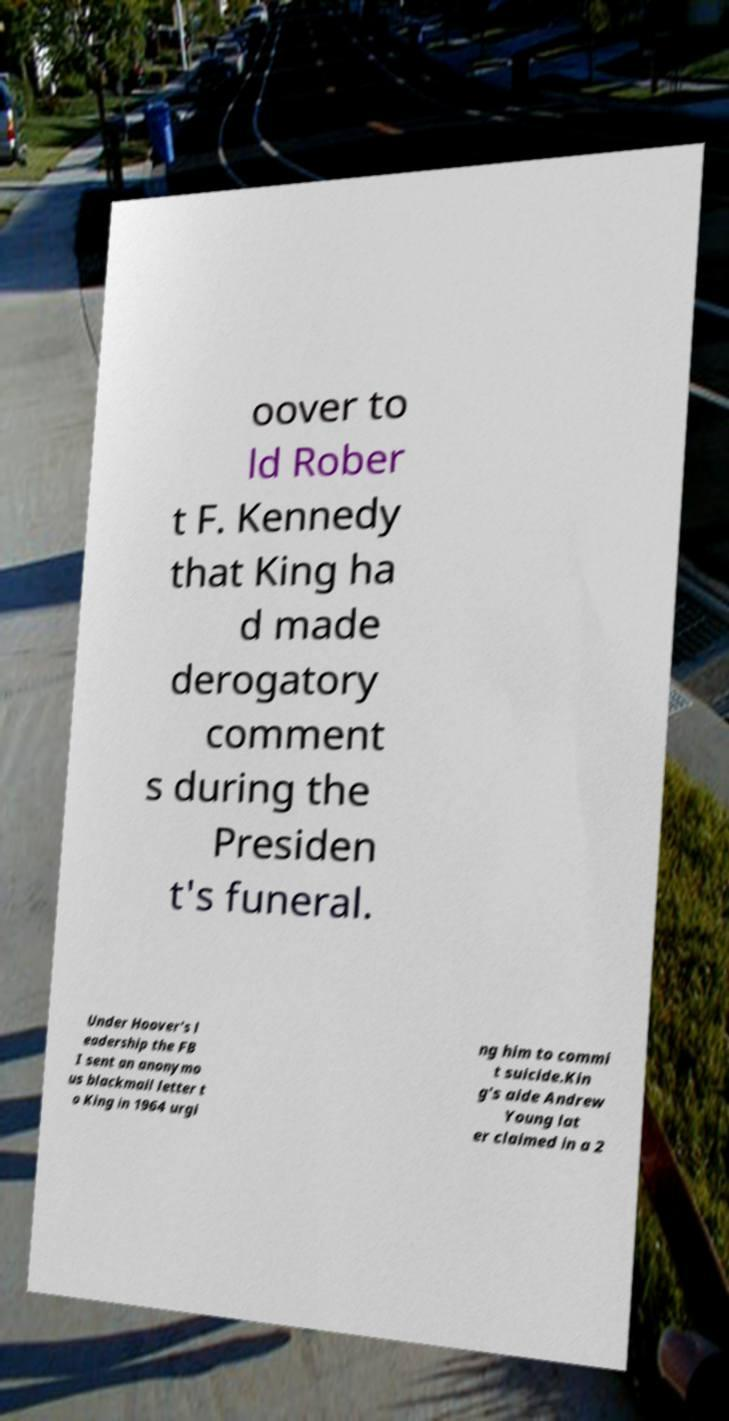Please identify and transcribe the text found in this image. oover to ld Rober t F. Kennedy that King ha d made derogatory comment s during the Presiden t's funeral. Under Hoover's l eadership the FB I sent an anonymo us blackmail letter t o King in 1964 urgi ng him to commi t suicide.Kin g's aide Andrew Young lat er claimed in a 2 